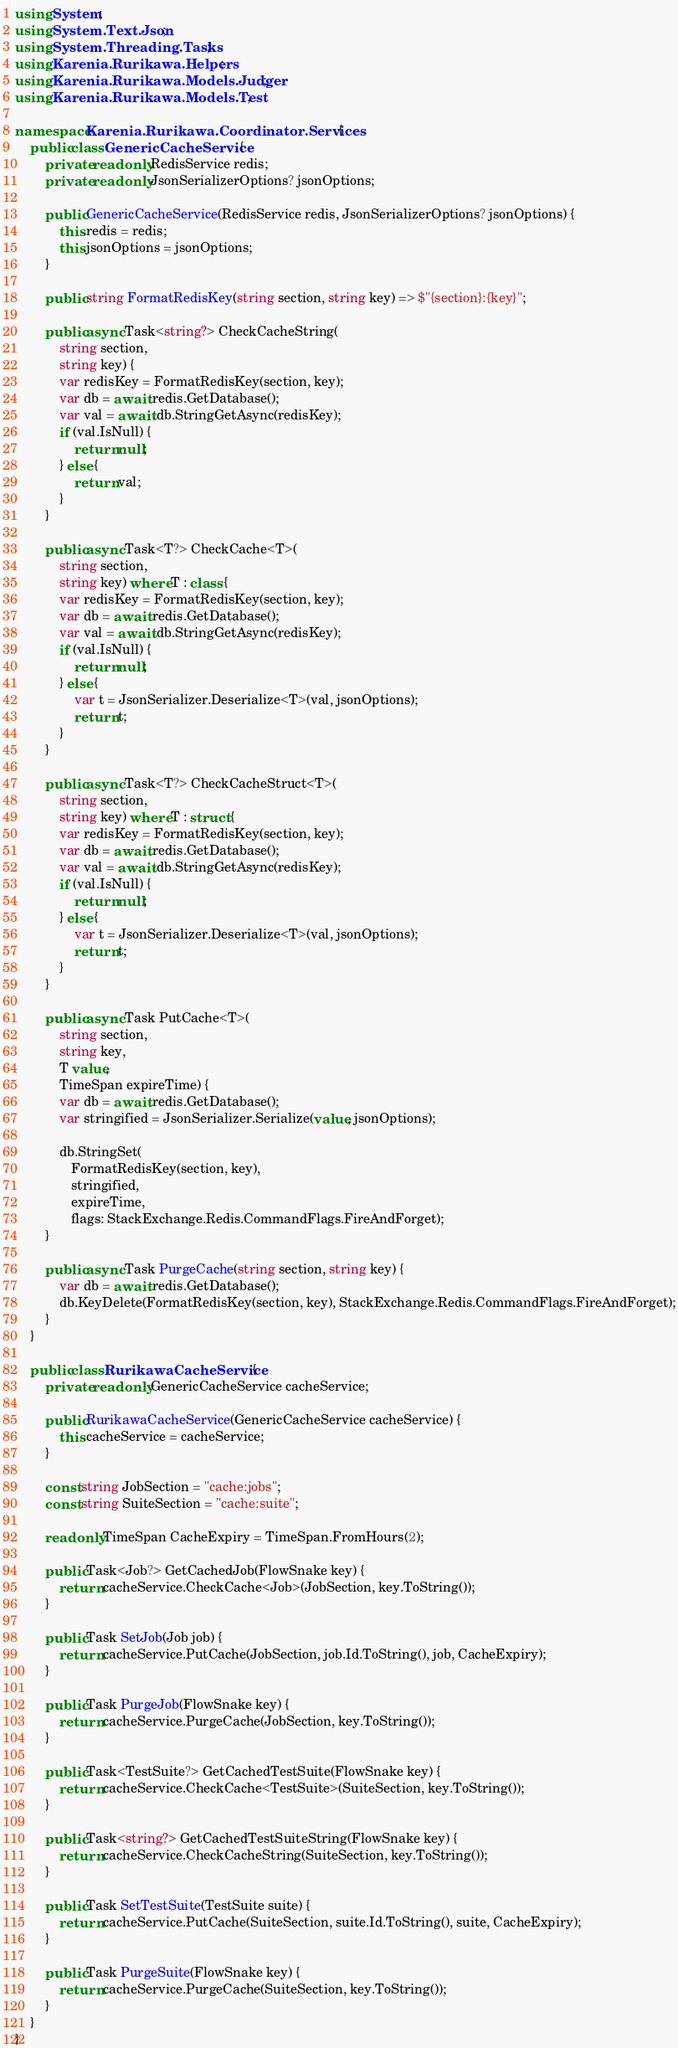Convert code to text. <code><loc_0><loc_0><loc_500><loc_500><_C#_>using System;
using System.Text.Json;
using System.Threading.Tasks;
using Karenia.Rurikawa.Helpers;
using Karenia.Rurikawa.Models.Judger;
using Karenia.Rurikawa.Models.Test;

namespace Karenia.Rurikawa.Coordinator.Services {
    public class GenericCacheService {
        private readonly RedisService redis;
        private readonly JsonSerializerOptions? jsonOptions;

        public GenericCacheService(RedisService redis, JsonSerializerOptions? jsonOptions) {
            this.redis = redis;
            this.jsonOptions = jsonOptions;
        }

        public string FormatRedisKey(string section, string key) => $"{section}:{key}";

        public async Task<string?> CheckCacheString(
            string section,
            string key) {
            var redisKey = FormatRedisKey(section, key);
            var db = await redis.GetDatabase();
            var val = await db.StringGetAsync(redisKey);
            if (val.IsNull) {
                return null;
            } else {
                return val;
            }
        }

        public async Task<T?> CheckCache<T>(
            string section,
            string key) where T : class {
            var redisKey = FormatRedisKey(section, key);
            var db = await redis.GetDatabase();
            var val = await db.StringGetAsync(redisKey);
            if (val.IsNull) {
                return null;
            } else {
                var t = JsonSerializer.Deserialize<T>(val, jsonOptions);
                return t;
            }
        }

        public async Task<T?> CheckCacheStruct<T>(
            string section,
            string key) where T : struct {
            var redisKey = FormatRedisKey(section, key);
            var db = await redis.GetDatabase();
            var val = await db.StringGetAsync(redisKey);
            if (val.IsNull) {
                return null;
            } else {
                var t = JsonSerializer.Deserialize<T>(val, jsonOptions);
                return t;
            }
        }

        public async Task PutCache<T>(
            string section,
            string key,
            T value,
            TimeSpan expireTime) {
            var db = await redis.GetDatabase();
            var stringified = JsonSerializer.Serialize(value, jsonOptions);

            db.StringSet(
               FormatRedisKey(section, key),
               stringified,
               expireTime,
               flags: StackExchange.Redis.CommandFlags.FireAndForget);
        }

        public async Task PurgeCache(string section, string key) {
            var db = await redis.GetDatabase();
            db.KeyDelete(FormatRedisKey(section, key), StackExchange.Redis.CommandFlags.FireAndForget);
        }
    }

    public class RurikawaCacheService {
        private readonly GenericCacheService cacheService;

        public RurikawaCacheService(GenericCacheService cacheService) {
            this.cacheService = cacheService;
        }

        const string JobSection = "cache:jobs";
        const string SuiteSection = "cache:suite";

        readonly TimeSpan CacheExpiry = TimeSpan.FromHours(2);

        public Task<Job?> GetCachedJob(FlowSnake key) {
            return cacheService.CheckCache<Job>(JobSection, key.ToString());
        }

        public Task SetJob(Job job) {
            return cacheService.PutCache(JobSection, job.Id.ToString(), job, CacheExpiry);
        }

        public Task PurgeJob(FlowSnake key) {
            return cacheService.PurgeCache(JobSection, key.ToString());
        }

        public Task<TestSuite?> GetCachedTestSuite(FlowSnake key) {
            return cacheService.CheckCache<TestSuite>(SuiteSection, key.ToString());
        }

        public Task<string?> GetCachedTestSuiteString(FlowSnake key) {
            return cacheService.CheckCacheString(SuiteSection, key.ToString());
        }

        public Task SetTestSuite(TestSuite suite) {
            return cacheService.PutCache(SuiteSection, suite.Id.ToString(), suite, CacheExpiry);
        }

        public Task PurgeSuite(FlowSnake key) {
            return cacheService.PurgeCache(SuiteSection, key.ToString());
        }
    }
}
</code> 